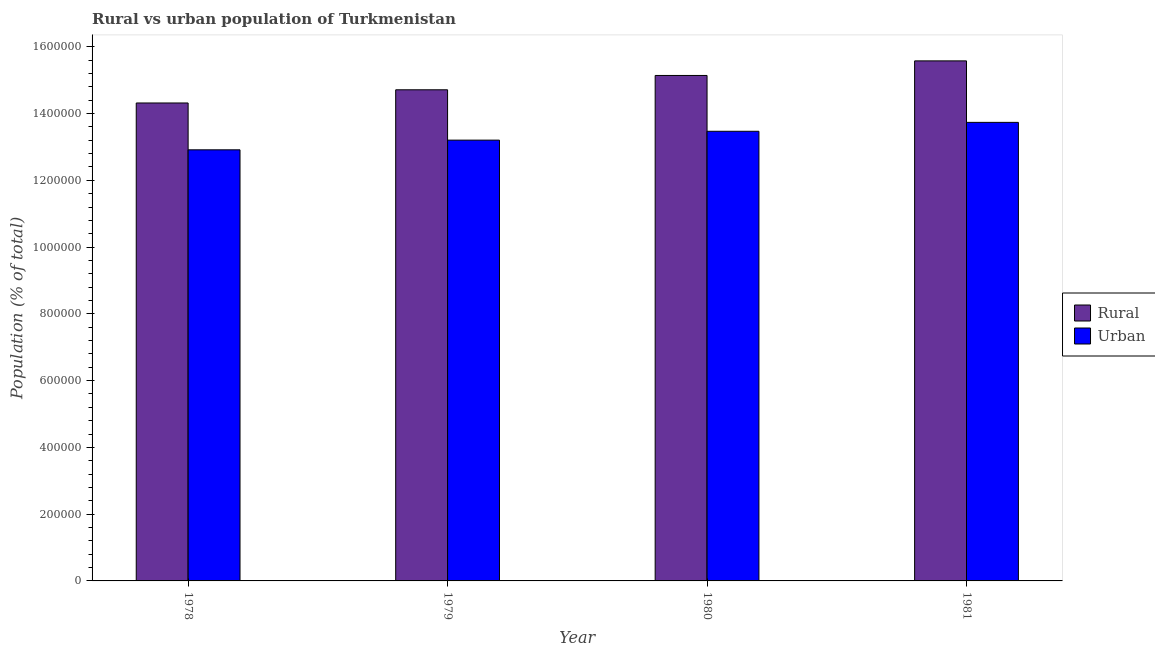How many different coloured bars are there?
Ensure brevity in your answer.  2. How many groups of bars are there?
Ensure brevity in your answer.  4. Are the number of bars on each tick of the X-axis equal?
Provide a short and direct response. Yes. How many bars are there on the 3rd tick from the left?
Your answer should be compact. 2. How many bars are there on the 3rd tick from the right?
Provide a short and direct response. 2. What is the label of the 2nd group of bars from the left?
Your answer should be very brief. 1979. What is the urban population density in 1979?
Your answer should be very brief. 1.32e+06. Across all years, what is the maximum rural population density?
Keep it short and to the point. 1.56e+06. Across all years, what is the minimum rural population density?
Make the answer very short. 1.43e+06. In which year was the rural population density minimum?
Provide a short and direct response. 1978. What is the total rural population density in the graph?
Provide a succinct answer. 5.97e+06. What is the difference between the rural population density in 1980 and that in 1981?
Your answer should be compact. -4.37e+04. What is the difference between the rural population density in 1981 and the urban population density in 1979?
Offer a terse response. 8.66e+04. What is the average urban population density per year?
Provide a succinct answer. 1.33e+06. In the year 1979, what is the difference between the urban population density and rural population density?
Provide a short and direct response. 0. What is the ratio of the rural population density in 1979 to that in 1980?
Your answer should be compact. 0.97. Is the difference between the urban population density in 1979 and 1980 greater than the difference between the rural population density in 1979 and 1980?
Keep it short and to the point. No. What is the difference between the highest and the second highest rural population density?
Offer a terse response. 4.37e+04. What is the difference between the highest and the lowest urban population density?
Your answer should be compact. 8.22e+04. In how many years, is the urban population density greater than the average urban population density taken over all years?
Your answer should be compact. 2. Is the sum of the urban population density in 1978 and 1980 greater than the maximum rural population density across all years?
Your response must be concise. Yes. What does the 2nd bar from the left in 1978 represents?
Give a very brief answer. Urban. What does the 2nd bar from the right in 1980 represents?
Your answer should be very brief. Rural. How many bars are there?
Make the answer very short. 8. How many years are there in the graph?
Your answer should be very brief. 4. What is the difference between two consecutive major ticks on the Y-axis?
Your response must be concise. 2.00e+05. Are the values on the major ticks of Y-axis written in scientific E-notation?
Your answer should be very brief. No. Does the graph contain any zero values?
Offer a very short reply. No. What is the title of the graph?
Offer a terse response. Rural vs urban population of Turkmenistan. Does "Private funds" appear as one of the legend labels in the graph?
Your response must be concise. No. What is the label or title of the Y-axis?
Provide a succinct answer. Population (% of total). What is the Population (% of total) in Rural in 1978?
Offer a very short reply. 1.43e+06. What is the Population (% of total) in Urban in 1978?
Your response must be concise. 1.29e+06. What is the Population (% of total) of Rural in 1979?
Offer a very short reply. 1.47e+06. What is the Population (% of total) in Urban in 1979?
Provide a short and direct response. 1.32e+06. What is the Population (% of total) in Rural in 1980?
Provide a succinct answer. 1.51e+06. What is the Population (% of total) in Urban in 1980?
Give a very brief answer. 1.35e+06. What is the Population (% of total) in Rural in 1981?
Offer a terse response. 1.56e+06. What is the Population (% of total) of Urban in 1981?
Your response must be concise. 1.37e+06. Across all years, what is the maximum Population (% of total) of Rural?
Keep it short and to the point. 1.56e+06. Across all years, what is the maximum Population (% of total) in Urban?
Provide a succinct answer. 1.37e+06. Across all years, what is the minimum Population (% of total) of Rural?
Give a very brief answer. 1.43e+06. Across all years, what is the minimum Population (% of total) of Urban?
Provide a short and direct response. 1.29e+06. What is the total Population (% of total) in Rural in the graph?
Your response must be concise. 5.97e+06. What is the total Population (% of total) in Urban in the graph?
Offer a very short reply. 5.33e+06. What is the difference between the Population (% of total) in Rural in 1978 and that in 1979?
Keep it short and to the point. -3.95e+04. What is the difference between the Population (% of total) of Urban in 1978 and that in 1979?
Provide a succinct answer. -2.90e+04. What is the difference between the Population (% of total) in Rural in 1978 and that in 1980?
Provide a succinct answer. -8.24e+04. What is the difference between the Population (% of total) of Urban in 1978 and that in 1980?
Provide a short and direct response. -5.55e+04. What is the difference between the Population (% of total) of Rural in 1978 and that in 1981?
Provide a short and direct response. -1.26e+05. What is the difference between the Population (% of total) in Urban in 1978 and that in 1981?
Your answer should be very brief. -8.22e+04. What is the difference between the Population (% of total) of Rural in 1979 and that in 1980?
Your answer should be very brief. -4.29e+04. What is the difference between the Population (% of total) in Urban in 1979 and that in 1980?
Make the answer very short. -2.65e+04. What is the difference between the Population (% of total) of Rural in 1979 and that in 1981?
Provide a succinct answer. -8.66e+04. What is the difference between the Population (% of total) of Urban in 1979 and that in 1981?
Ensure brevity in your answer.  -5.32e+04. What is the difference between the Population (% of total) in Rural in 1980 and that in 1981?
Ensure brevity in your answer.  -4.37e+04. What is the difference between the Population (% of total) in Urban in 1980 and that in 1981?
Keep it short and to the point. -2.67e+04. What is the difference between the Population (% of total) of Rural in 1978 and the Population (% of total) of Urban in 1979?
Provide a short and direct response. 1.11e+05. What is the difference between the Population (% of total) of Rural in 1978 and the Population (% of total) of Urban in 1980?
Offer a terse response. 8.47e+04. What is the difference between the Population (% of total) in Rural in 1978 and the Population (% of total) in Urban in 1981?
Your answer should be very brief. 5.81e+04. What is the difference between the Population (% of total) in Rural in 1979 and the Population (% of total) in Urban in 1980?
Your answer should be very brief. 1.24e+05. What is the difference between the Population (% of total) in Rural in 1979 and the Population (% of total) in Urban in 1981?
Your answer should be compact. 9.76e+04. What is the difference between the Population (% of total) of Rural in 1980 and the Population (% of total) of Urban in 1981?
Give a very brief answer. 1.41e+05. What is the average Population (% of total) in Rural per year?
Provide a succinct answer. 1.49e+06. What is the average Population (% of total) in Urban per year?
Offer a terse response. 1.33e+06. In the year 1978, what is the difference between the Population (% of total) of Rural and Population (% of total) of Urban?
Give a very brief answer. 1.40e+05. In the year 1979, what is the difference between the Population (% of total) of Rural and Population (% of total) of Urban?
Your answer should be compact. 1.51e+05. In the year 1980, what is the difference between the Population (% of total) of Rural and Population (% of total) of Urban?
Offer a very short reply. 1.67e+05. In the year 1981, what is the difference between the Population (% of total) of Rural and Population (% of total) of Urban?
Your answer should be compact. 1.84e+05. What is the ratio of the Population (% of total) of Rural in 1978 to that in 1979?
Your response must be concise. 0.97. What is the ratio of the Population (% of total) in Rural in 1978 to that in 1980?
Make the answer very short. 0.95. What is the ratio of the Population (% of total) of Urban in 1978 to that in 1980?
Make the answer very short. 0.96. What is the ratio of the Population (% of total) in Rural in 1978 to that in 1981?
Offer a very short reply. 0.92. What is the ratio of the Population (% of total) of Urban in 1978 to that in 1981?
Provide a short and direct response. 0.94. What is the ratio of the Population (% of total) in Rural in 1979 to that in 1980?
Provide a succinct answer. 0.97. What is the ratio of the Population (% of total) in Urban in 1979 to that in 1980?
Provide a short and direct response. 0.98. What is the ratio of the Population (% of total) of Rural in 1979 to that in 1981?
Your answer should be compact. 0.94. What is the ratio of the Population (% of total) in Urban in 1979 to that in 1981?
Provide a succinct answer. 0.96. What is the ratio of the Population (% of total) of Rural in 1980 to that in 1981?
Your response must be concise. 0.97. What is the ratio of the Population (% of total) in Urban in 1980 to that in 1981?
Provide a succinct answer. 0.98. What is the difference between the highest and the second highest Population (% of total) in Rural?
Your answer should be compact. 4.37e+04. What is the difference between the highest and the second highest Population (% of total) of Urban?
Give a very brief answer. 2.67e+04. What is the difference between the highest and the lowest Population (% of total) in Rural?
Make the answer very short. 1.26e+05. What is the difference between the highest and the lowest Population (% of total) of Urban?
Make the answer very short. 8.22e+04. 